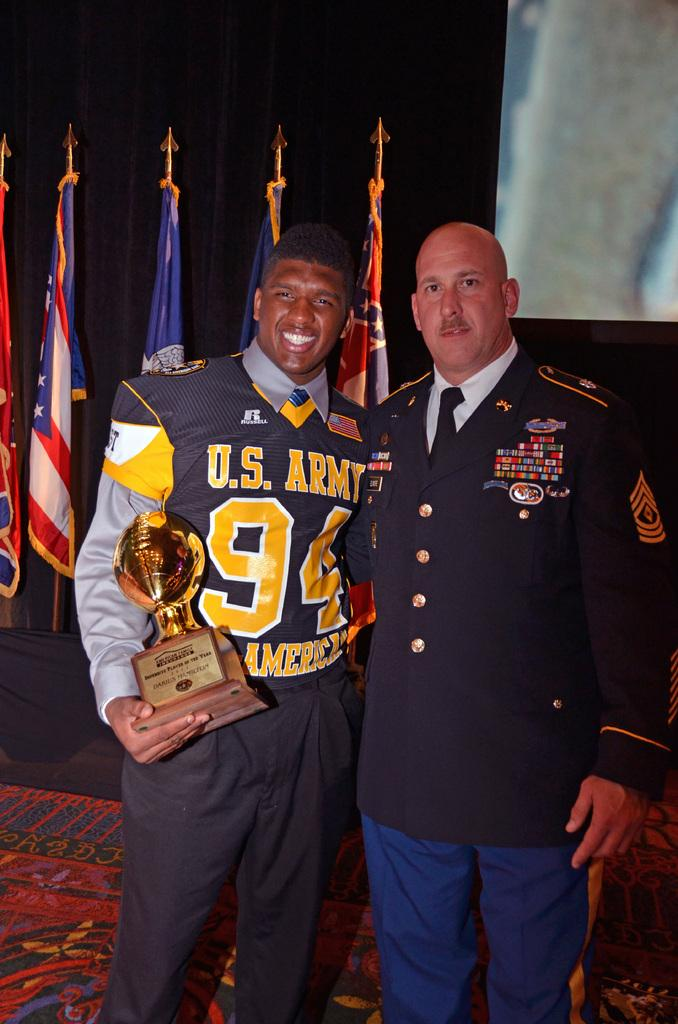<image>
Relay a brief, clear account of the picture shown. U.S. Army football player is holding on to an award in the shape of a gold football while standing next to a very decorated military officer. 